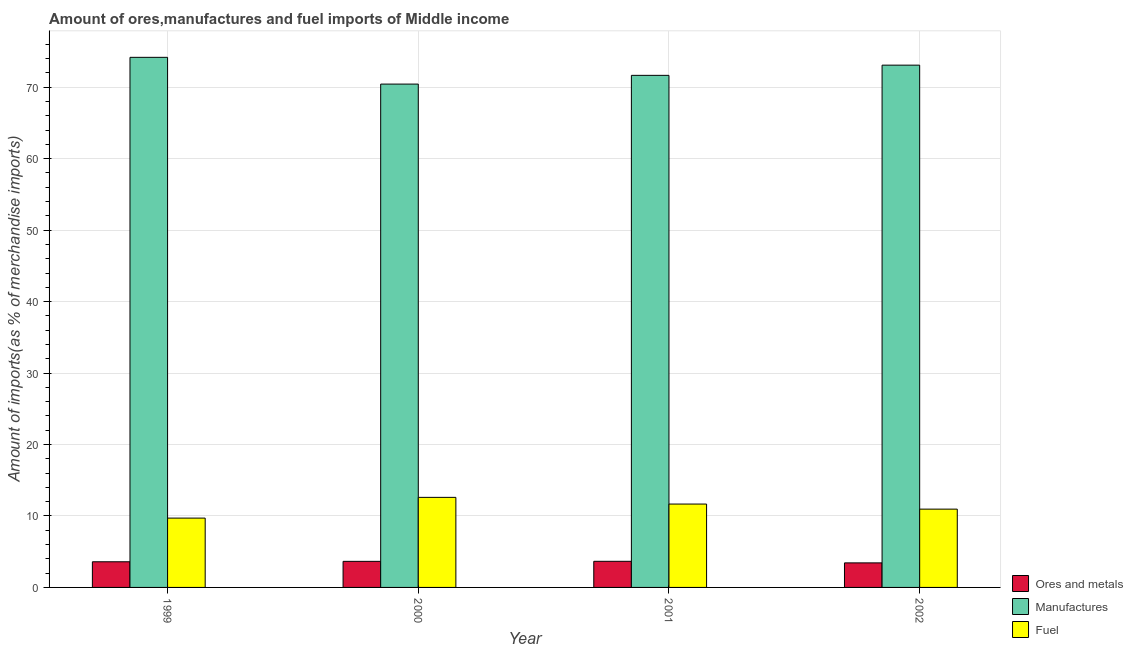How many different coloured bars are there?
Offer a very short reply. 3. Are the number of bars on each tick of the X-axis equal?
Keep it short and to the point. Yes. How many bars are there on the 3rd tick from the left?
Provide a short and direct response. 3. How many bars are there on the 2nd tick from the right?
Offer a very short reply. 3. What is the label of the 3rd group of bars from the left?
Keep it short and to the point. 2001. In how many cases, is the number of bars for a given year not equal to the number of legend labels?
Make the answer very short. 0. What is the percentage of ores and metals imports in 1999?
Make the answer very short. 3.59. Across all years, what is the maximum percentage of ores and metals imports?
Your answer should be very brief. 3.66. Across all years, what is the minimum percentage of ores and metals imports?
Your answer should be very brief. 3.43. What is the total percentage of ores and metals imports in the graph?
Your response must be concise. 14.33. What is the difference between the percentage of ores and metals imports in 1999 and that in 2002?
Your answer should be very brief. 0.16. What is the difference between the percentage of manufactures imports in 2000 and the percentage of ores and metals imports in 2001?
Keep it short and to the point. -1.22. What is the average percentage of ores and metals imports per year?
Keep it short and to the point. 3.58. What is the ratio of the percentage of fuel imports in 1999 to that in 2002?
Give a very brief answer. 0.89. What is the difference between the highest and the second highest percentage of ores and metals imports?
Your answer should be compact. 0.01. What is the difference between the highest and the lowest percentage of manufactures imports?
Provide a short and direct response. 3.74. Is the sum of the percentage of ores and metals imports in 2000 and 2002 greater than the maximum percentage of manufactures imports across all years?
Ensure brevity in your answer.  Yes. What does the 3rd bar from the left in 1999 represents?
Keep it short and to the point. Fuel. What does the 2nd bar from the right in 2000 represents?
Your answer should be compact. Manufactures. Is it the case that in every year, the sum of the percentage of ores and metals imports and percentage of manufactures imports is greater than the percentage of fuel imports?
Your answer should be very brief. Yes. What is the difference between two consecutive major ticks on the Y-axis?
Offer a very short reply. 10. What is the title of the graph?
Offer a terse response. Amount of ores,manufactures and fuel imports of Middle income. What is the label or title of the Y-axis?
Offer a very short reply. Amount of imports(as % of merchandise imports). What is the Amount of imports(as % of merchandise imports) in Ores and metals in 1999?
Give a very brief answer. 3.59. What is the Amount of imports(as % of merchandise imports) in Manufactures in 1999?
Provide a succinct answer. 74.19. What is the Amount of imports(as % of merchandise imports) of Fuel in 1999?
Make the answer very short. 9.7. What is the Amount of imports(as % of merchandise imports) of Ores and metals in 2000?
Provide a succinct answer. 3.65. What is the Amount of imports(as % of merchandise imports) of Manufactures in 2000?
Your answer should be very brief. 70.44. What is the Amount of imports(as % of merchandise imports) in Fuel in 2000?
Ensure brevity in your answer.  12.6. What is the Amount of imports(as % of merchandise imports) in Ores and metals in 2001?
Provide a succinct answer. 3.66. What is the Amount of imports(as % of merchandise imports) in Manufactures in 2001?
Give a very brief answer. 71.66. What is the Amount of imports(as % of merchandise imports) of Fuel in 2001?
Give a very brief answer. 11.67. What is the Amount of imports(as % of merchandise imports) in Ores and metals in 2002?
Ensure brevity in your answer.  3.43. What is the Amount of imports(as % of merchandise imports) in Manufactures in 2002?
Keep it short and to the point. 73.09. What is the Amount of imports(as % of merchandise imports) of Fuel in 2002?
Keep it short and to the point. 10.96. Across all years, what is the maximum Amount of imports(as % of merchandise imports) in Ores and metals?
Your answer should be very brief. 3.66. Across all years, what is the maximum Amount of imports(as % of merchandise imports) in Manufactures?
Make the answer very short. 74.19. Across all years, what is the maximum Amount of imports(as % of merchandise imports) in Fuel?
Your response must be concise. 12.6. Across all years, what is the minimum Amount of imports(as % of merchandise imports) of Ores and metals?
Ensure brevity in your answer.  3.43. Across all years, what is the minimum Amount of imports(as % of merchandise imports) of Manufactures?
Your response must be concise. 70.44. Across all years, what is the minimum Amount of imports(as % of merchandise imports) in Fuel?
Your response must be concise. 9.7. What is the total Amount of imports(as % of merchandise imports) in Ores and metals in the graph?
Your answer should be compact. 14.33. What is the total Amount of imports(as % of merchandise imports) of Manufactures in the graph?
Provide a short and direct response. 289.39. What is the total Amount of imports(as % of merchandise imports) in Fuel in the graph?
Your answer should be compact. 44.93. What is the difference between the Amount of imports(as % of merchandise imports) of Ores and metals in 1999 and that in 2000?
Offer a terse response. -0.06. What is the difference between the Amount of imports(as % of merchandise imports) in Manufactures in 1999 and that in 2000?
Provide a short and direct response. 3.74. What is the difference between the Amount of imports(as % of merchandise imports) in Fuel in 1999 and that in 2000?
Ensure brevity in your answer.  -2.9. What is the difference between the Amount of imports(as % of merchandise imports) of Ores and metals in 1999 and that in 2001?
Make the answer very short. -0.07. What is the difference between the Amount of imports(as % of merchandise imports) of Manufactures in 1999 and that in 2001?
Make the answer very short. 2.52. What is the difference between the Amount of imports(as % of merchandise imports) in Fuel in 1999 and that in 2001?
Your answer should be compact. -1.96. What is the difference between the Amount of imports(as % of merchandise imports) in Ores and metals in 1999 and that in 2002?
Make the answer very short. 0.16. What is the difference between the Amount of imports(as % of merchandise imports) in Manufactures in 1999 and that in 2002?
Make the answer very short. 1.09. What is the difference between the Amount of imports(as % of merchandise imports) of Fuel in 1999 and that in 2002?
Your response must be concise. -1.26. What is the difference between the Amount of imports(as % of merchandise imports) in Ores and metals in 2000 and that in 2001?
Your answer should be compact. -0.01. What is the difference between the Amount of imports(as % of merchandise imports) in Manufactures in 2000 and that in 2001?
Offer a terse response. -1.22. What is the difference between the Amount of imports(as % of merchandise imports) in Fuel in 2000 and that in 2001?
Make the answer very short. 0.94. What is the difference between the Amount of imports(as % of merchandise imports) in Ores and metals in 2000 and that in 2002?
Your response must be concise. 0.21. What is the difference between the Amount of imports(as % of merchandise imports) of Manufactures in 2000 and that in 2002?
Give a very brief answer. -2.65. What is the difference between the Amount of imports(as % of merchandise imports) in Fuel in 2000 and that in 2002?
Give a very brief answer. 1.65. What is the difference between the Amount of imports(as % of merchandise imports) of Ores and metals in 2001 and that in 2002?
Give a very brief answer. 0.22. What is the difference between the Amount of imports(as % of merchandise imports) in Manufactures in 2001 and that in 2002?
Offer a terse response. -1.43. What is the difference between the Amount of imports(as % of merchandise imports) in Fuel in 2001 and that in 2002?
Keep it short and to the point. 0.71. What is the difference between the Amount of imports(as % of merchandise imports) in Ores and metals in 1999 and the Amount of imports(as % of merchandise imports) in Manufactures in 2000?
Offer a terse response. -66.85. What is the difference between the Amount of imports(as % of merchandise imports) of Ores and metals in 1999 and the Amount of imports(as % of merchandise imports) of Fuel in 2000?
Ensure brevity in your answer.  -9.01. What is the difference between the Amount of imports(as % of merchandise imports) in Manufactures in 1999 and the Amount of imports(as % of merchandise imports) in Fuel in 2000?
Your answer should be very brief. 61.58. What is the difference between the Amount of imports(as % of merchandise imports) of Ores and metals in 1999 and the Amount of imports(as % of merchandise imports) of Manufactures in 2001?
Keep it short and to the point. -68.07. What is the difference between the Amount of imports(as % of merchandise imports) in Ores and metals in 1999 and the Amount of imports(as % of merchandise imports) in Fuel in 2001?
Your response must be concise. -8.08. What is the difference between the Amount of imports(as % of merchandise imports) of Manufactures in 1999 and the Amount of imports(as % of merchandise imports) of Fuel in 2001?
Your answer should be compact. 62.52. What is the difference between the Amount of imports(as % of merchandise imports) in Ores and metals in 1999 and the Amount of imports(as % of merchandise imports) in Manufactures in 2002?
Your answer should be compact. -69.5. What is the difference between the Amount of imports(as % of merchandise imports) in Ores and metals in 1999 and the Amount of imports(as % of merchandise imports) in Fuel in 2002?
Give a very brief answer. -7.37. What is the difference between the Amount of imports(as % of merchandise imports) in Manufactures in 1999 and the Amount of imports(as % of merchandise imports) in Fuel in 2002?
Your answer should be very brief. 63.23. What is the difference between the Amount of imports(as % of merchandise imports) of Ores and metals in 2000 and the Amount of imports(as % of merchandise imports) of Manufactures in 2001?
Keep it short and to the point. -68.02. What is the difference between the Amount of imports(as % of merchandise imports) of Ores and metals in 2000 and the Amount of imports(as % of merchandise imports) of Fuel in 2001?
Offer a terse response. -8.02. What is the difference between the Amount of imports(as % of merchandise imports) in Manufactures in 2000 and the Amount of imports(as % of merchandise imports) in Fuel in 2001?
Your answer should be very brief. 58.78. What is the difference between the Amount of imports(as % of merchandise imports) in Ores and metals in 2000 and the Amount of imports(as % of merchandise imports) in Manufactures in 2002?
Give a very brief answer. -69.44. What is the difference between the Amount of imports(as % of merchandise imports) in Ores and metals in 2000 and the Amount of imports(as % of merchandise imports) in Fuel in 2002?
Offer a very short reply. -7.31. What is the difference between the Amount of imports(as % of merchandise imports) in Manufactures in 2000 and the Amount of imports(as % of merchandise imports) in Fuel in 2002?
Provide a short and direct response. 59.48. What is the difference between the Amount of imports(as % of merchandise imports) of Ores and metals in 2001 and the Amount of imports(as % of merchandise imports) of Manufactures in 2002?
Make the answer very short. -69.44. What is the difference between the Amount of imports(as % of merchandise imports) of Ores and metals in 2001 and the Amount of imports(as % of merchandise imports) of Fuel in 2002?
Provide a succinct answer. -7.3. What is the difference between the Amount of imports(as % of merchandise imports) of Manufactures in 2001 and the Amount of imports(as % of merchandise imports) of Fuel in 2002?
Offer a terse response. 60.71. What is the average Amount of imports(as % of merchandise imports) of Ores and metals per year?
Ensure brevity in your answer.  3.58. What is the average Amount of imports(as % of merchandise imports) in Manufactures per year?
Offer a very short reply. 72.35. What is the average Amount of imports(as % of merchandise imports) in Fuel per year?
Offer a terse response. 11.23. In the year 1999, what is the difference between the Amount of imports(as % of merchandise imports) of Ores and metals and Amount of imports(as % of merchandise imports) of Manufactures?
Ensure brevity in your answer.  -70.6. In the year 1999, what is the difference between the Amount of imports(as % of merchandise imports) of Ores and metals and Amount of imports(as % of merchandise imports) of Fuel?
Offer a terse response. -6.11. In the year 1999, what is the difference between the Amount of imports(as % of merchandise imports) of Manufactures and Amount of imports(as % of merchandise imports) of Fuel?
Provide a short and direct response. 64.48. In the year 2000, what is the difference between the Amount of imports(as % of merchandise imports) in Ores and metals and Amount of imports(as % of merchandise imports) in Manufactures?
Your answer should be very brief. -66.79. In the year 2000, what is the difference between the Amount of imports(as % of merchandise imports) of Ores and metals and Amount of imports(as % of merchandise imports) of Fuel?
Offer a terse response. -8.95. In the year 2000, what is the difference between the Amount of imports(as % of merchandise imports) of Manufactures and Amount of imports(as % of merchandise imports) of Fuel?
Ensure brevity in your answer.  57.84. In the year 2001, what is the difference between the Amount of imports(as % of merchandise imports) in Ores and metals and Amount of imports(as % of merchandise imports) in Manufactures?
Offer a terse response. -68.01. In the year 2001, what is the difference between the Amount of imports(as % of merchandise imports) in Ores and metals and Amount of imports(as % of merchandise imports) in Fuel?
Give a very brief answer. -8.01. In the year 2001, what is the difference between the Amount of imports(as % of merchandise imports) of Manufactures and Amount of imports(as % of merchandise imports) of Fuel?
Offer a terse response. 60. In the year 2002, what is the difference between the Amount of imports(as % of merchandise imports) of Ores and metals and Amount of imports(as % of merchandise imports) of Manufactures?
Make the answer very short. -69.66. In the year 2002, what is the difference between the Amount of imports(as % of merchandise imports) of Ores and metals and Amount of imports(as % of merchandise imports) of Fuel?
Provide a short and direct response. -7.52. In the year 2002, what is the difference between the Amount of imports(as % of merchandise imports) in Manufactures and Amount of imports(as % of merchandise imports) in Fuel?
Give a very brief answer. 62.13. What is the ratio of the Amount of imports(as % of merchandise imports) of Manufactures in 1999 to that in 2000?
Your answer should be very brief. 1.05. What is the ratio of the Amount of imports(as % of merchandise imports) in Fuel in 1999 to that in 2000?
Your response must be concise. 0.77. What is the ratio of the Amount of imports(as % of merchandise imports) of Ores and metals in 1999 to that in 2001?
Provide a short and direct response. 0.98. What is the ratio of the Amount of imports(as % of merchandise imports) of Manufactures in 1999 to that in 2001?
Keep it short and to the point. 1.04. What is the ratio of the Amount of imports(as % of merchandise imports) of Fuel in 1999 to that in 2001?
Offer a very short reply. 0.83. What is the ratio of the Amount of imports(as % of merchandise imports) in Ores and metals in 1999 to that in 2002?
Offer a terse response. 1.05. What is the ratio of the Amount of imports(as % of merchandise imports) in Fuel in 1999 to that in 2002?
Keep it short and to the point. 0.89. What is the ratio of the Amount of imports(as % of merchandise imports) in Manufactures in 2000 to that in 2001?
Give a very brief answer. 0.98. What is the ratio of the Amount of imports(as % of merchandise imports) of Fuel in 2000 to that in 2001?
Keep it short and to the point. 1.08. What is the ratio of the Amount of imports(as % of merchandise imports) of Ores and metals in 2000 to that in 2002?
Provide a succinct answer. 1.06. What is the ratio of the Amount of imports(as % of merchandise imports) of Manufactures in 2000 to that in 2002?
Offer a very short reply. 0.96. What is the ratio of the Amount of imports(as % of merchandise imports) in Fuel in 2000 to that in 2002?
Your response must be concise. 1.15. What is the ratio of the Amount of imports(as % of merchandise imports) of Ores and metals in 2001 to that in 2002?
Ensure brevity in your answer.  1.06. What is the ratio of the Amount of imports(as % of merchandise imports) of Manufactures in 2001 to that in 2002?
Your answer should be very brief. 0.98. What is the ratio of the Amount of imports(as % of merchandise imports) in Fuel in 2001 to that in 2002?
Ensure brevity in your answer.  1.06. What is the difference between the highest and the second highest Amount of imports(as % of merchandise imports) of Ores and metals?
Offer a very short reply. 0.01. What is the difference between the highest and the second highest Amount of imports(as % of merchandise imports) in Manufactures?
Offer a very short reply. 1.09. What is the difference between the highest and the second highest Amount of imports(as % of merchandise imports) in Fuel?
Provide a succinct answer. 0.94. What is the difference between the highest and the lowest Amount of imports(as % of merchandise imports) of Ores and metals?
Keep it short and to the point. 0.22. What is the difference between the highest and the lowest Amount of imports(as % of merchandise imports) in Manufactures?
Keep it short and to the point. 3.74. What is the difference between the highest and the lowest Amount of imports(as % of merchandise imports) in Fuel?
Make the answer very short. 2.9. 